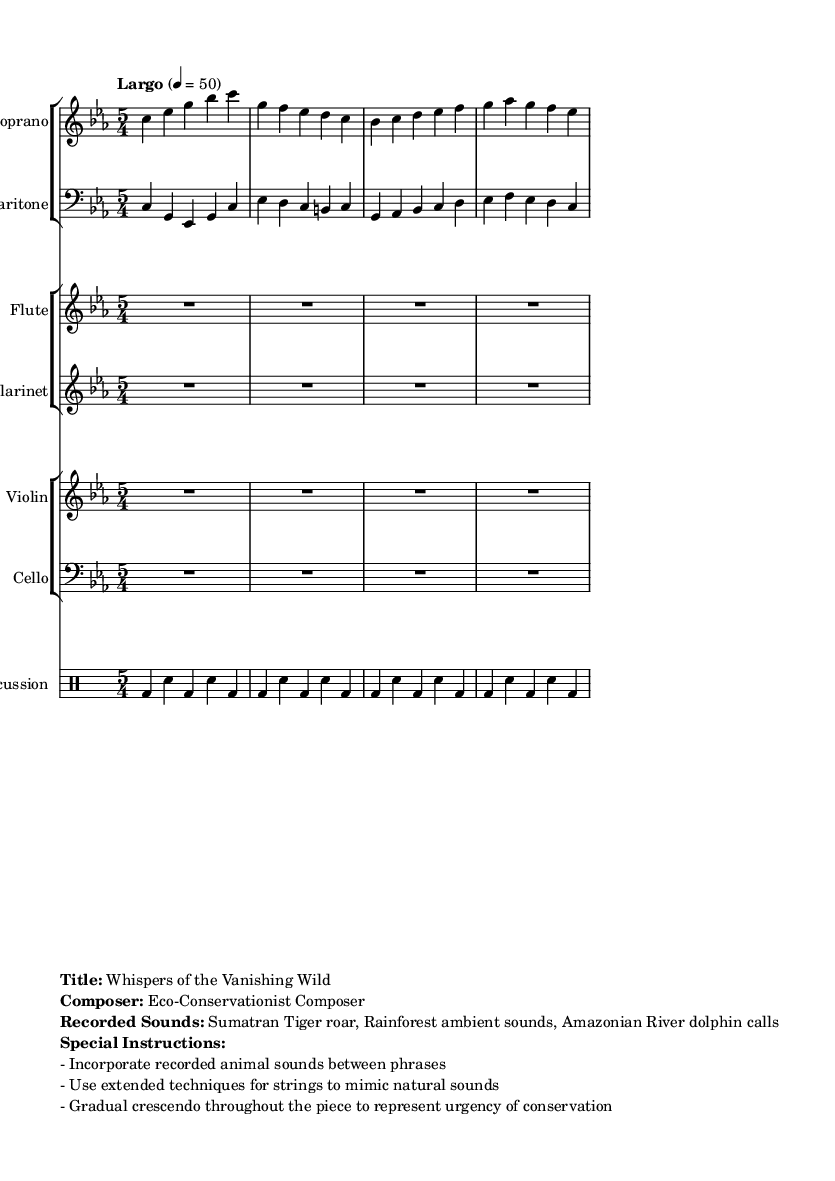What is the key signature of this music? The key signature is C minor, indicated by three flats in the staff.
Answer: C minor What is the time signature of this piece? The time signature is indicated at the beginning of the score, labeled as five over four (5/4), which shows that there are five beats per measure.
Answer: 5/4 What is the tempo marking used in this music? The tempo marking is specified below the clef signature as "Largo," indicating a slow tempo. The exact beats per minute are provided as 50.
Answer: Largo How many instruments are featured in this opera score? By counting the individual staff groups, there are five instrument groups: soprano, baritone, flute, clarinet, violin, cello, and timpani, which sums up to eight instruments in total.
Answer: Eight What are the main recorded sounds featured in the opera? The recorded sounds are specified in the markup section of the score, which lists them as "Sumatran Tiger roar, Rainforest ambient sounds, Amazonian River dolphin calls."
Answer: Sumatran Tiger roar, Rainforest ambient sounds, Amazonian River dolphin calls What special instructions are mentioned for the performance? The sheet music includes specific performance notes that highlight the requirements: to incorporate recorded animal sounds between phrases, use extended techniques for strings, and create a gradual crescendo throughout the piece to represent urgency.
Answer: Incorporate recorded animal sounds, extended techniques, gradual crescendo What does the gradual crescendo represent in this piece? According to the performance instructions provided in the markup, the gradual crescendo is intended to symbolize the urgency of conservation, reflecting the themes of the opera.
Answer: Urgency of conservation 